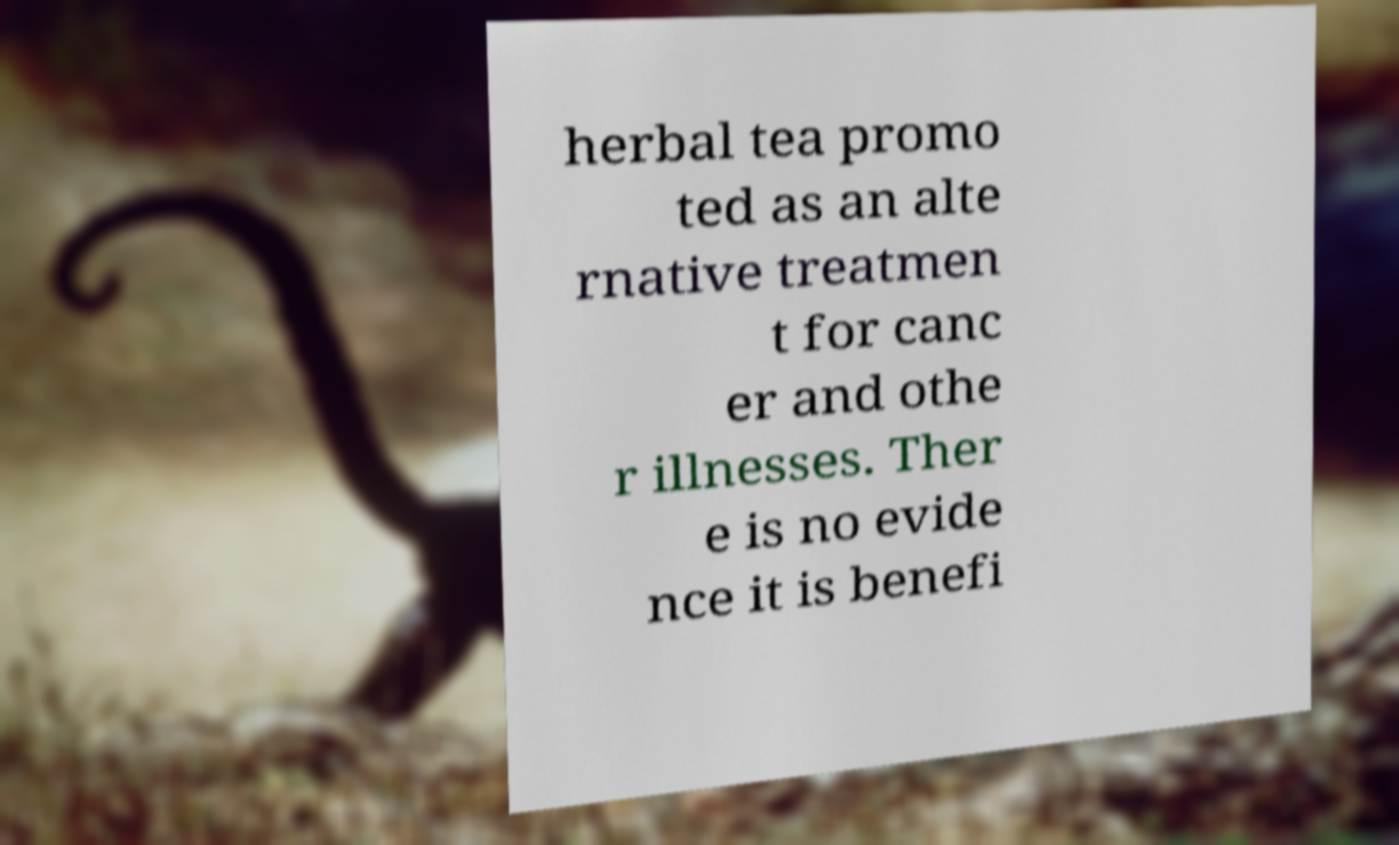I need the written content from this picture converted into text. Can you do that? herbal tea promo ted as an alte rnative treatmen t for canc er and othe r illnesses. Ther e is no evide nce it is benefi 